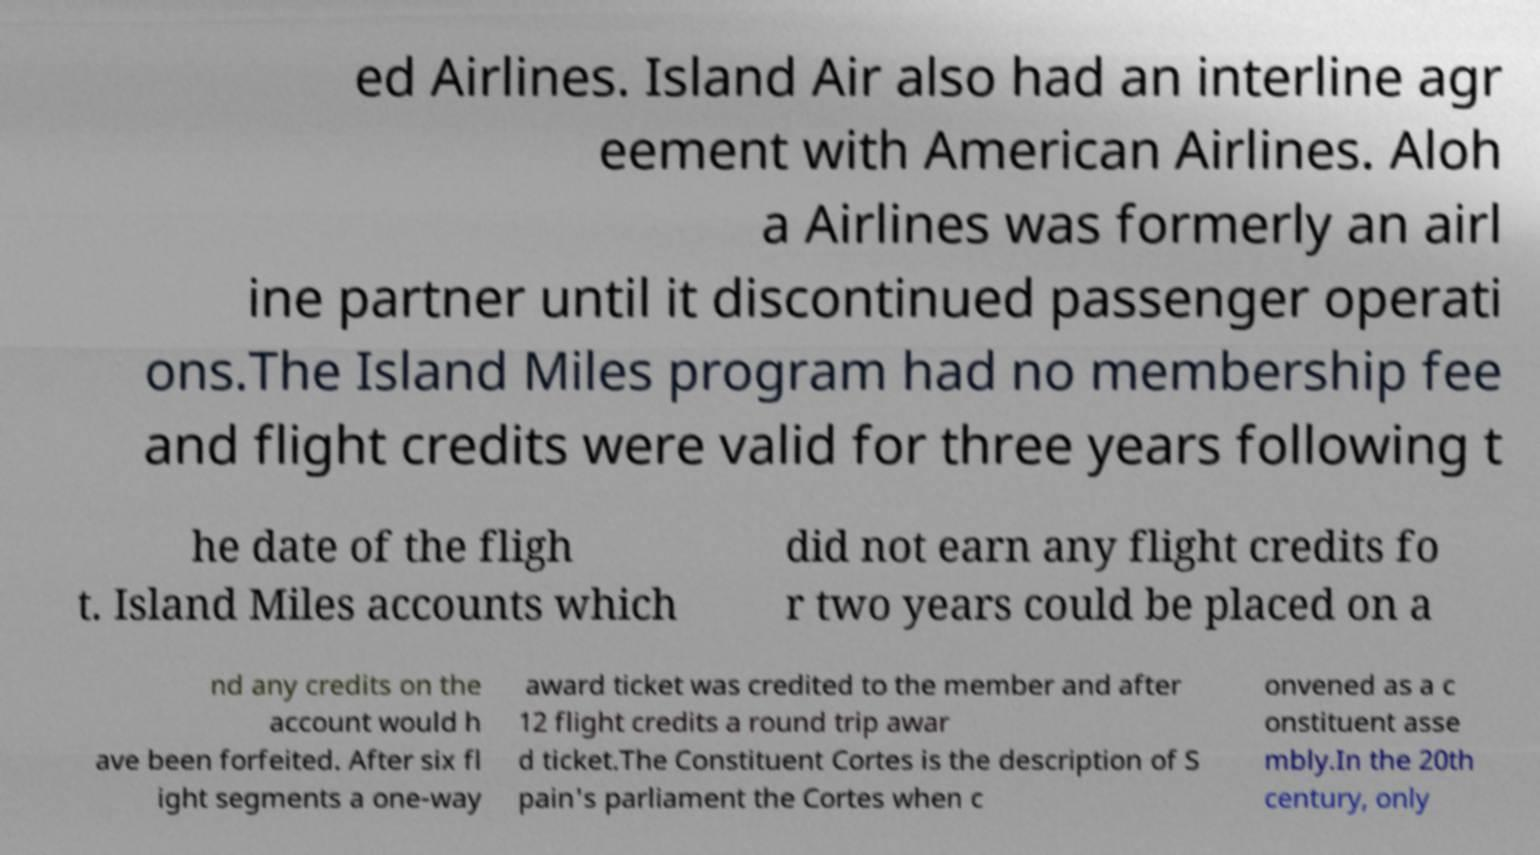What messages or text are displayed in this image? I need them in a readable, typed format. ed Airlines. Island Air also had an interline agr eement with American Airlines. Aloh a Airlines was formerly an airl ine partner until it discontinued passenger operati ons.The Island Miles program had no membership fee and flight credits were valid for three years following t he date of the fligh t. Island Miles accounts which did not earn any flight credits fo r two years could be placed on a nd any credits on the account would h ave been forfeited. After six fl ight segments a one-way award ticket was credited to the member and after 12 flight credits a round trip awar d ticket.The Constituent Cortes is the description of S pain's parliament the Cortes when c onvened as a c onstituent asse mbly.In the 20th century, only 